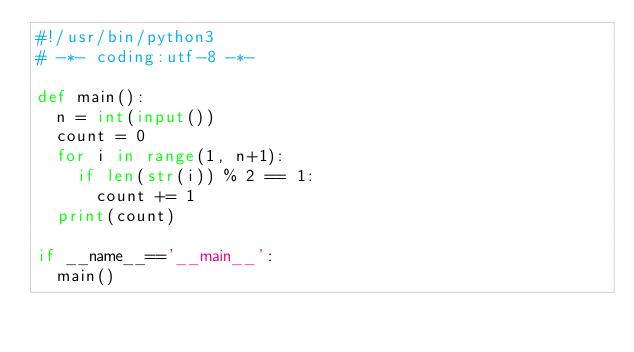<code> <loc_0><loc_0><loc_500><loc_500><_Python_>#!/usr/bin/python3
# -*- coding:utf-8 -*-

def main():
  n = int(input())
  count = 0
  for i in range(1, n+1):
    if len(str(i)) % 2 == 1:
      count += 1
  print(count)

if __name__=='__main__':
  main()

</code> 